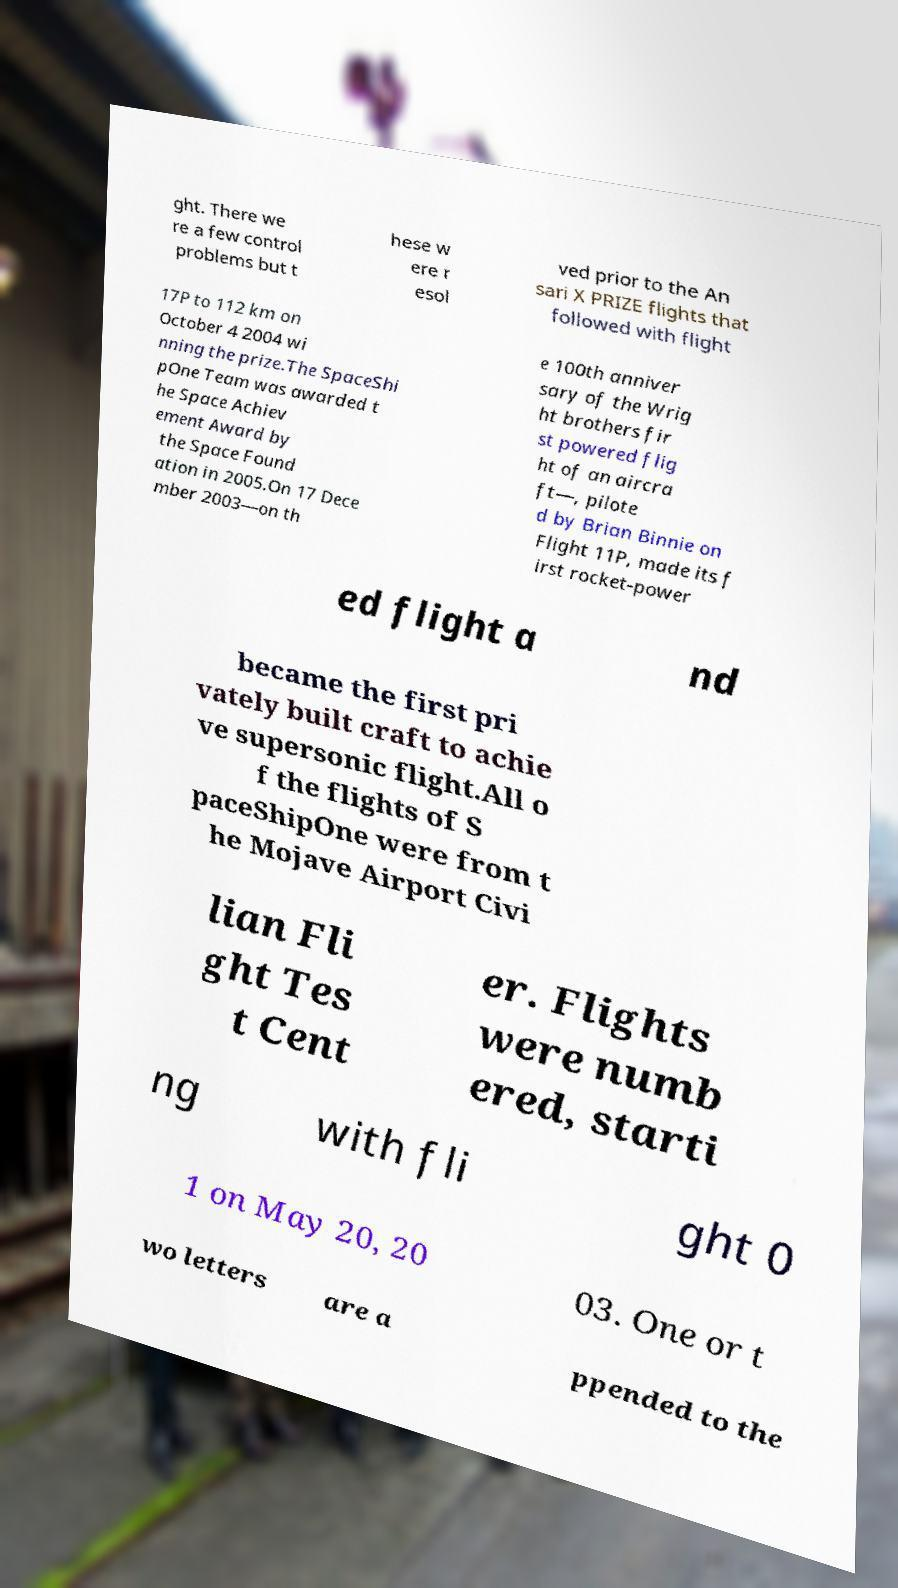For documentation purposes, I need the text within this image transcribed. Could you provide that? ght. There we re a few control problems but t hese w ere r esol ved prior to the An sari X PRIZE flights that followed with flight 17P to 112 km on October 4 2004 wi nning the prize.The SpaceShi pOne Team was awarded t he Space Achiev ement Award by the Space Found ation in 2005.On 17 Dece mber 2003—on th e 100th anniver sary of the Wrig ht brothers fir st powered flig ht of an aircra ft—, pilote d by Brian Binnie on Flight 11P, made its f irst rocket-power ed flight a nd became the first pri vately built craft to achie ve supersonic flight.All o f the flights of S paceShipOne were from t he Mojave Airport Civi lian Fli ght Tes t Cent er. Flights were numb ered, starti ng with fli ght 0 1 on May 20, 20 03. One or t wo letters are a ppended to the 